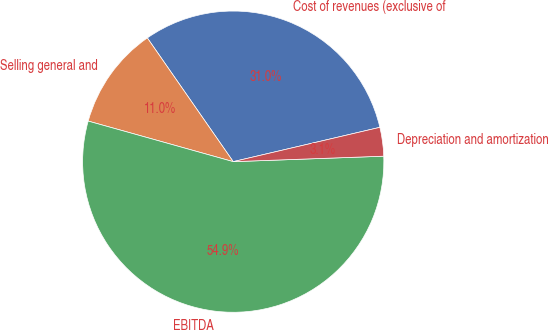Convert chart to OTSL. <chart><loc_0><loc_0><loc_500><loc_500><pie_chart><fcel>Cost of revenues (exclusive of<fcel>Selling general and<fcel>EBITDA<fcel>Depreciation and amortization<nl><fcel>31.0%<fcel>11.0%<fcel>54.92%<fcel>3.08%<nl></chart> 